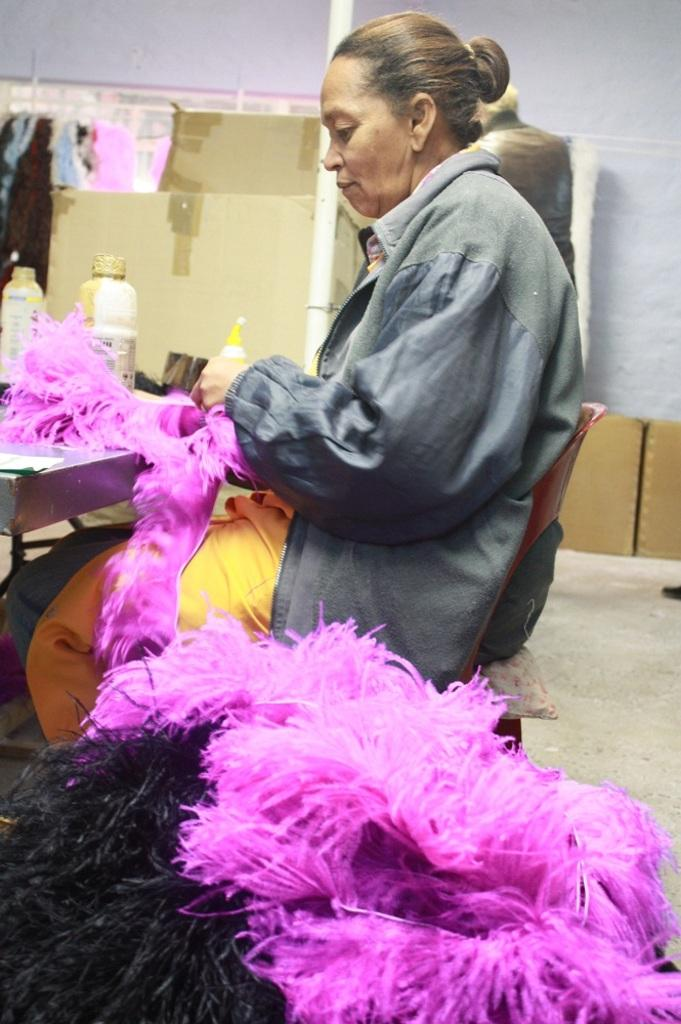What is the woman in the image doing? The woman is sitting on a chair in the image. What is located near the woman? There is a table in the image. What can be seen on the table? There are bottles and other objects on the table. What is visible in the background of the image? There is a wall, boxes, and a person in the background of the image. Is there a slope visible in the image? No, there is no slope present in the image. 